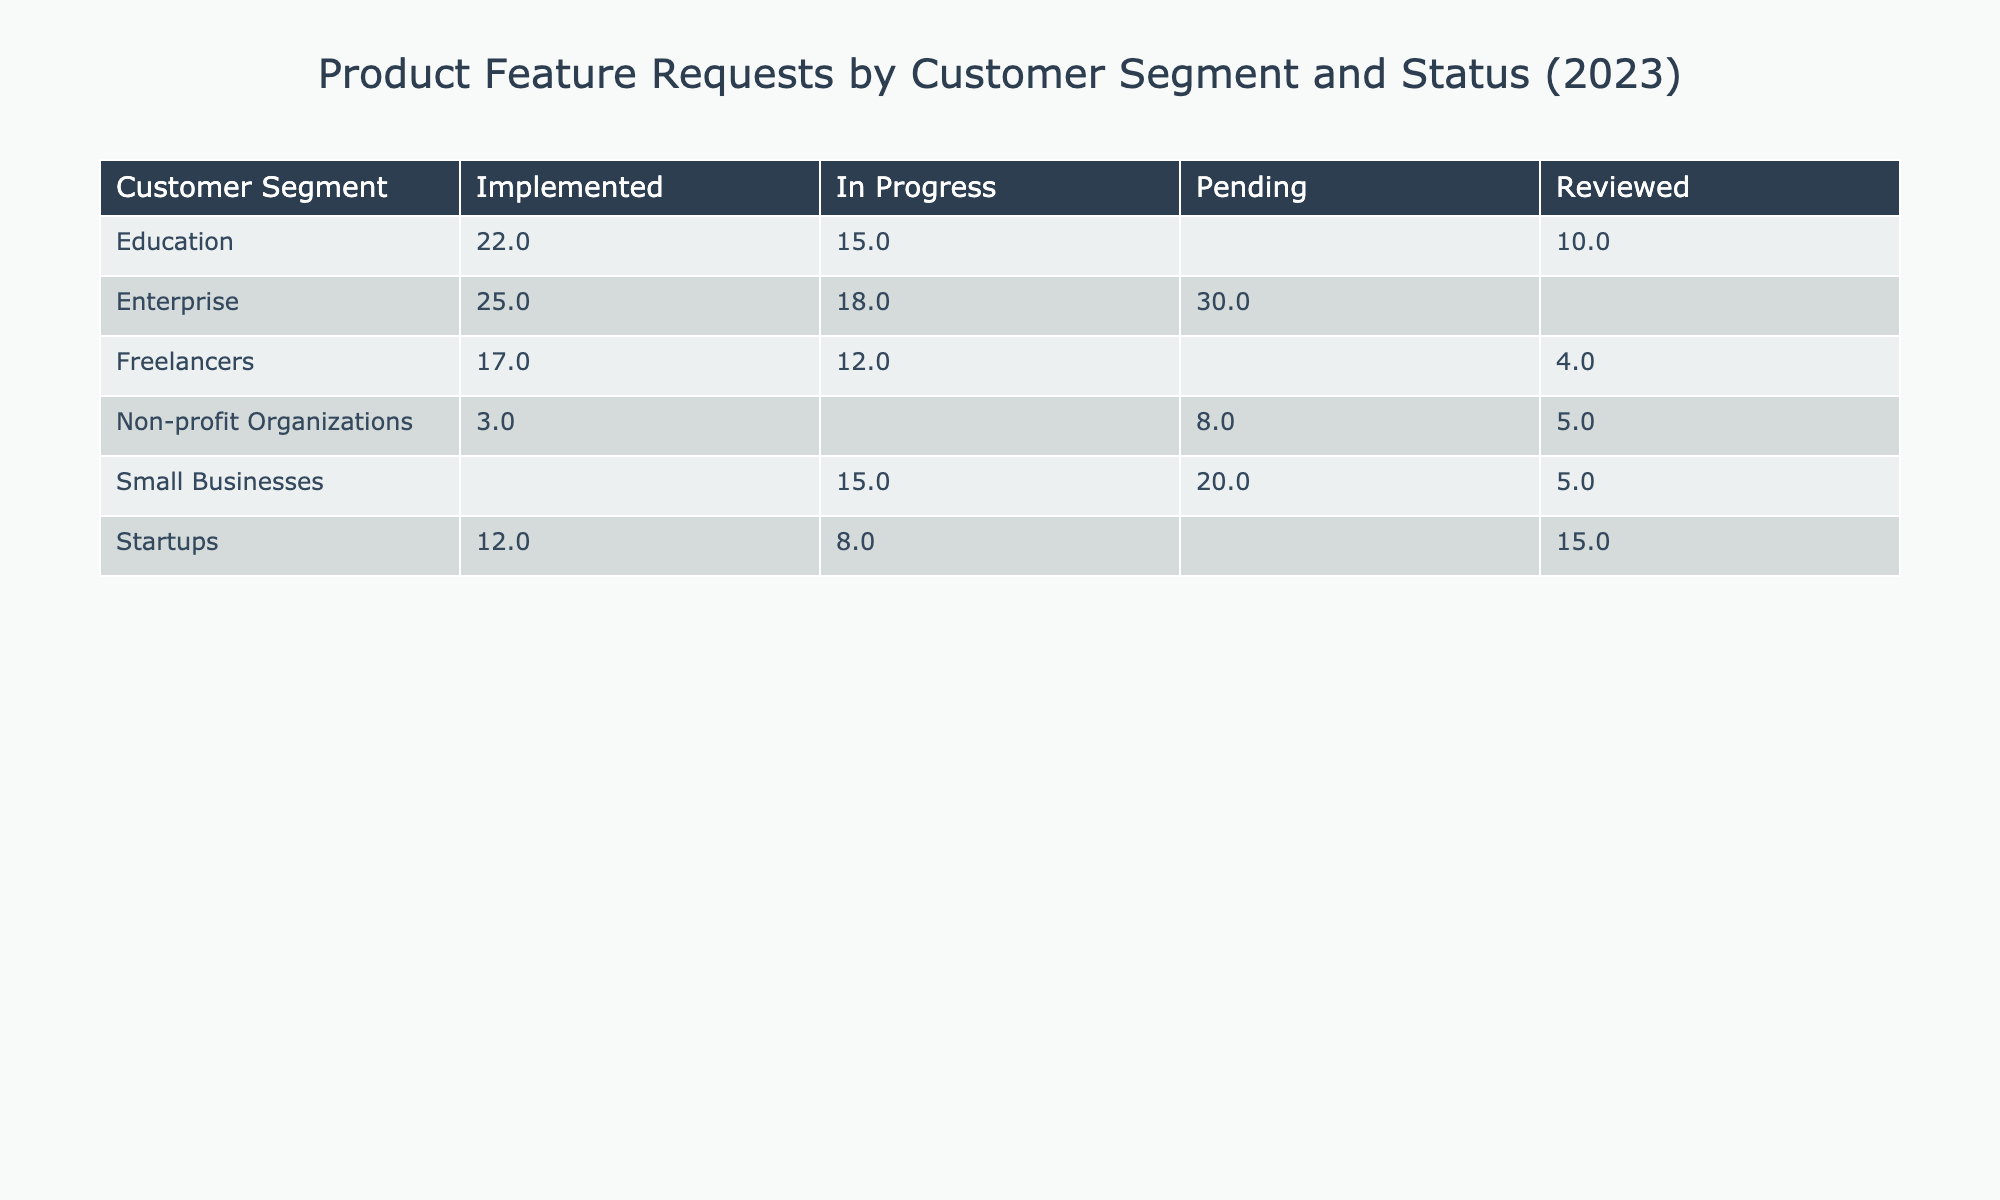What is the total number of feature requests from Small Businesses? In the table, the feature requests from Small Businesses are Automated Reports (20), API Access (15), and Advanced Analytics (5). Adding these together gives 20 + 15 + 5 = 40.
Answer: 40 How many feature requests from the Education segment are still pending? The table shows that the Education segment has Enhanced Security Features (15) which is In Progress, but there are no requests with a Pending status. Therefore, the answer is 0.
Answer: 0 Which customer segment has the highest count of feature requests? By comparing the request counts for each customer segment, Startups have 35 (15 + 8 + 12), Small Businesses have 40, Enterprise has 73 (25 + 30 + 18), Education has 47 (10 + 15 + 22), Non-profit Organizations have 16, and Freelancers have 33 (12 + 17 + 4). The Enterprise segment with 73 has the highest.
Answer: Enterprise Are there any features from the Non-profit Organizations segment that are implemented? The table shows that Donation Tracking (3) is marked as Implemented. Thus, there is at least one implemented feature request.
Answer: Yes What is the difference in request counts between Implemented features and Pending features in the Enterprise segment? In the Enterprise segment, the Implemented features are Single Sign-On (25) and Data Encryption (30); hence the total is 25 + 30 = 55. The only Pending feature is Data Encryption (30). Therefore, the difference is 55 - 30 = 25.
Answer: 25 How many total feature requests are there for Startups? The feature requests for Startups include Real-time Collaboration (15), Custom Branding (8), and Mobile App Integration (12). Summing these yields 15 + 8 + 12 = 35.
Answer: 35 What percentage of requests from Freelancers are implemented? Freelancers have 12 requests for Time Tracking (In Progress), 17 for Invoice Customization (Implemented), and 4 for Client Portal (Reviewed), amounting to 33 total requests. The implemented requests are 17. The percentage is (17/33) * 100 ≈ 51.52%.
Answer: Approximately 51.52% Is there any overlap between Education and Non-profit Organizations in the types of feature requests made? Reviewing the feature requests, Education has Discount Pricing, Enhanced Security Features, and Interactive Learning Tools, while Non-profit Organizations have Grant Management Tool, Donation Tracking, and Volunteer Scheduling. There are no identical requests between the two segments.
Answer: No Which segment has the least number of Reviewed feature requests? By checking the Reviewed features: Startups (1), Small Businesses (1), Enterprise (0), Education (1), Non-profit Organizations (1), and Freelancers (1). The segment with the least is Enterprise with 0.
Answer: Enterprise How many features are in progress for each customer segment? Startups have 1 In Progress feature, Small Businesses have 2, Enterprise has 1, Education has 1, Non-profit Organizations has 1, and Freelancers have 1. Summing these gives: 1 + 2 + 1 + 1 + 1 + 1 = 7.
Answer: 7 